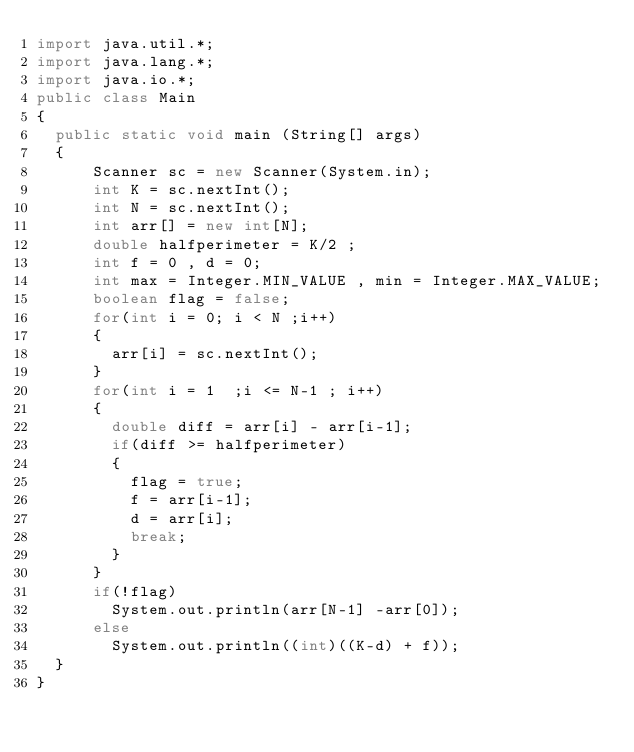<code> <loc_0><loc_0><loc_500><loc_500><_Java_>import java.util.*;
import java.lang.*;
import java.io.*;
public class Main
{
	public static void main (String[] args)
	{
			Scanner sc = new Scanner(System.in);
			int K = sc.nextInt();
			int N = sc.nextInt();
			int arr[] = new int[N];
			double halfperimeter = K/2 ;
			int f = 0 , d = 0;
			int max = Integer.MIN_VALUE , min = Integer.MAX_VALUE;
			boolean flag = false;
			for(int i = 0; i < N ;i++)
			{
				arr[i] = sc.nextInt();							
			}
			for(int i = 1  ;i <= N-1 ; i++)
			{
				double diff = arr[i] - arr[i-1];
				if(diff >= halfperimeter)
				{
					flag = true;
					f = arr[i-1];
					d = arr[i];
					break;
				}
			}
			if(!flag)
				System.out.println(arr[N-1] -arr[0]);
			else
				System.out.println((int)((K-d) + f));			
	}
}
</code> 